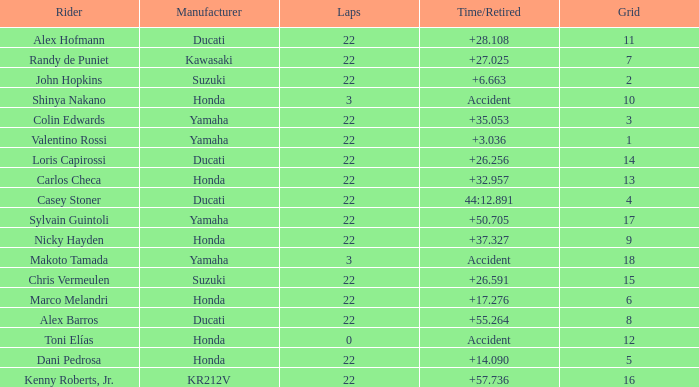What is the average grid for competitors who had more than 22 laps and time/retired of +17.276? None. 